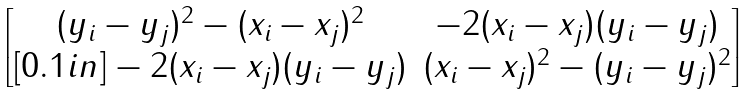<formula> <loc_0><loc_0><loc_500><loc_500>\begin{bmatrix} ( y _ { i } - y _ { j } ) ^ { 2 } - ( x _ { i } - x _ { j } ) ^ { 2 } & - 2 ( x _ { i } - x _ { j } ) ( y _ { i } - y _ { j } ) \\ [ 0 . 1 i n ] - 2 ( x _ { i } - x _ { j } ) ( y _ { i } - y _ { j } ) & ( x _ { i } - x _ { j } ) ^ { 2 } - ( y _ { i } - y _ { j } ) ^ { 2 } \end{bmatrix}</formula> 